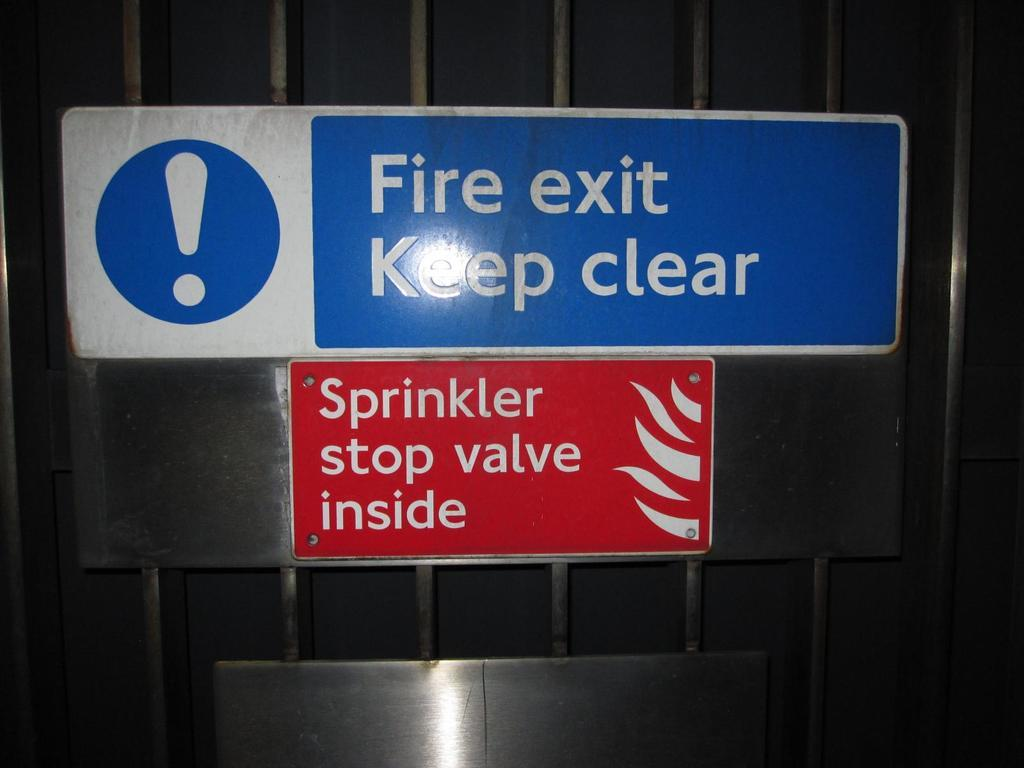<image>
Present a compact description of the photo's key features. A sign that reads fire exit and one that reads Sprinkler stop valve inside. 